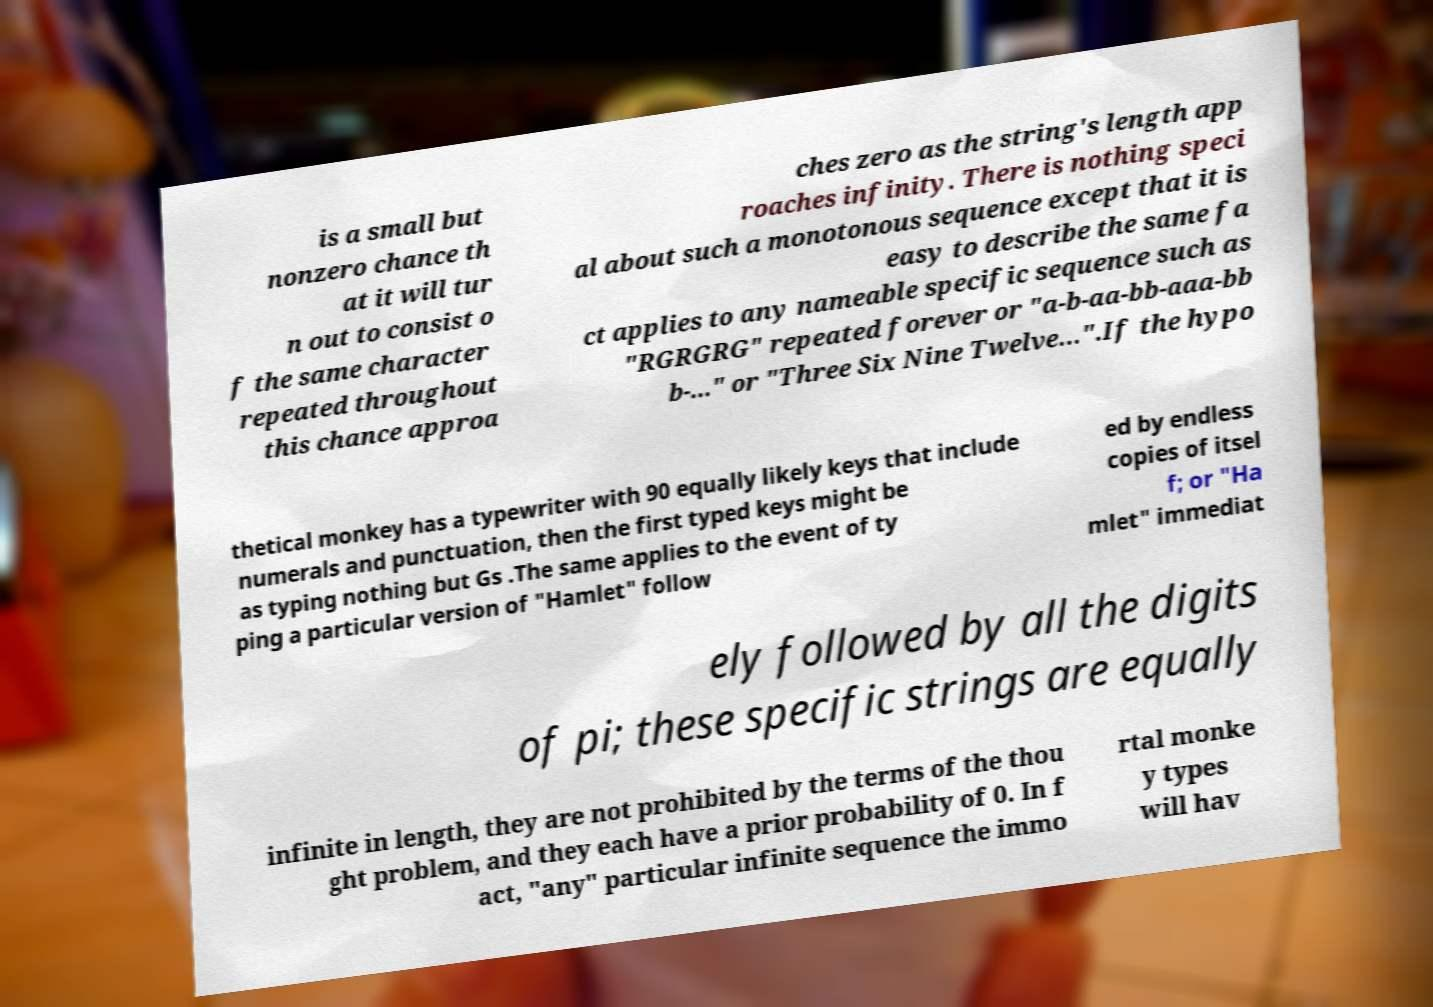What messages or text are displayed in this image? I need them in a readable, typed format. is a small but nonzero chance th at it will tur n out to consist o f the same character repeated throughout this chance approa ches zero as the string's length app roaches infinity. There is nothing speci al about such a monotonous sequence except that it is easy to describe the same fa ct applies to any nameable specific sequence such as "RGRGRG" repeated forever or "a-b-aa-bb-aaa-bb b-..." or "Three Six Nine Twelve…".If the hypo thetical monkey has a typewriter with 90 equally likely keys that include numerals and punctuation, then the first typed keys might be as typing nothing but Gs .The same applies to the event of ty ping a particular version of "Hamlet" follow ed by endless copies of itsel f; or "Ha mlet" immediat ely followed by all the digits of pi; these specific strings are equally infinite in length, they are not prohibited by the terms of the thou ght problem, and they each have a prior probability of 0. In f act, "any" particular infinite sequence the immo rtal monke y types will hav 